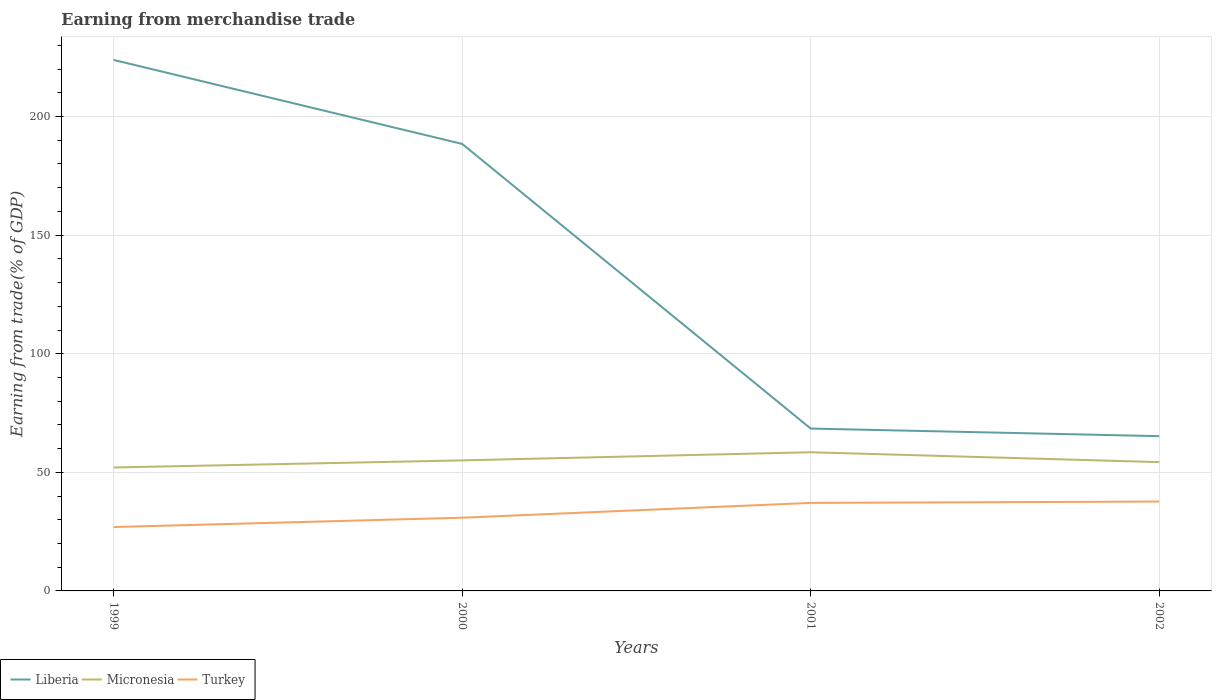Does the line corresponding to Micronesia intersect with the line corresponding to Turkey?
Make the answer very short. No. Is the number of lines equal to the number of legend labels?
Ensure brevity in your answer.  Yes. Across all years, what is the maximum earnings from trade in Liberia?
Give a very brief answer. 65.25. In which year was the earnings from trade in Liberia maximum?
Make the answer very short. 2002. What is the total earnings from trade in Micronesia in the graph?
Make the answer very short. -6.42. What is the difference between the highest and the second highest earnings from trade in Turkey?
Offer a very short reply. 10.75. What is the difference between the highest and the lowest earnings from trade in Micronesia?
Ensure brevity in your answer.  2. How many years are there in the graph?
Provide a short and direct response. 4. Does the graph contain grids?
Offer a very short reply. Yes. How are the legend labels stacked?
Offer a terse response. Horizontal. What is the title of the graph?
Your answer should be compact. Earning from merchandise trade. Does "Madagascar" appear as one of the legend labels in the graph?
Ensure brevity in your answer.  No. What is the label or title of the Y-axis?
Your response must be concise. Earning from trade(% of GDP). What is the Earning from trade(% of GDP) of Liberia in 1999?
Offer a very short reply. 223.86. What is the Earning from trade(% of GDP) of Micronesia in 1999?
Make the answer very short. 52.04. What is the Earning from trade(% of GDP) of Turkey in 1999?
Keep it short and to the point. 26.93. What is the Earning from trade(% of GDP) of Liberia in 2000?
Provide a short and direct response. 188.45. What is the Earning from trade(% of GDP) of Micronesia in 2000?
Your answer should be very brief. 55.04. What is the Earning from trade(% of GDP) in Turkey in 2000?
Offer a terse response. 30.87. What is the Earning from trade(% of GDP) of Liberia in 2001?
Keep it short and to the point. 68.45. What is the Earning from trade(% of GDP) of Micronesia in 2001?
Ensure brevity in your answer.  58.46. What is the Earning from trade(% of GDP) of Turkey in 2001?
Provide a short and direct response. 37.11. What is the Earning from trade(% of GDP) in Liberia in 2002?
Ensure brevity in your answer.  65.25. What is the Earning from trade(% of GDP) of Micronesia in 2002?
Your answer should be compact. 54.3. What is the Earning from trade(% of GDP) in Turkey in 2002?
Give a very brief answer. 37.68. Across all years, what is the maximum Earning from trade(% of GDP) of Liberia?
Your answer should be compact. 223.86. Across all years, what is the maximum Earning from trade(% of GDP) in Micronesia?
Make the answer very short. 58.46. Across all years, what is the maximum Earning from trade(% of GDP) of Turkey?
Your response must be concise. 37.68. Across all years, what is the minimum Earning from trade(% of GDP) of Liberia?
Your answer should be compact. 65.25. Across all years, what is the minimum Earning from trade(% of GDP) of Micronesia?
Your answer should be very brief. 52.04. Across all years, what is the minimum Earning from trade(% of GDP) of Turkey?
Give a very brief answer. 26.93. What is the total Earning from trade(% of GDP) of Liberia in the graph?
Offer a terse response. 546. What is the total Earning from trade(% of GDP) in Micronesia in the graph?
Provide a succinct answer. 219.84. What is the total Earning from trade(% of GDP) in Turkey in the graph?
Give a very brief answer. 132.58. What is the difference between the Earning from trade(% of GDP) in Liberia in 1999 and that in 2000?
Offer a very short reply. 35.41. What is the difference between the Earning from trade(% of GDP) in Micronesia in 1999 and that in 2000?
Provide a short and direct response. -3. What is the difference between the Earning from trade(% of GDP) in Turkey in 1999 and that in 2000?
Make the answer very short. -3.94. What is the difference between the Earning from trade(% of GDP) in Liberia in 1999 and that in 2001?
Provide a short and direct response. 155.41. What is the difference between the Earning from trade(% of GDP) in Micronesia in 1999 and that in 2001?
Keep it short and to the point. -6.42. What is the difference between the Earning from trade(% of GDP) of Turkey in 1999 and that in 2001?
Keep it short and to the point. -10.18. What is the difference between the Earning from trade(% of GDP) in Liberia in 1999 and that in 2002?
Ensure brevity in your answer.  158.61. What is the difference between the Earning from trade(% of GDP) of Micronesia in 1999 and that in 2002?
Give a very brief answer. -2.26. What is the difference between the Earning from trade(% of GDP) in Turkey in 1999 and that in 2002?
Your answer should be very brief. -10.75. What is the difference between the Earning from trade(% of GDP) of Liberia in 2000 and that in 2001?
Your response must be concise. 120. What is the difference between the Earning from trade(% of GDP) of Micronesia in 2000 and that in 2001?
Give a very brief answer. -3.42. What is the difference between the Earning from trade(% of GDP) in Turkey in 2000 and that in 2001?
Offer a terse response. -6.24. What is the difference between the Earning from trade(% of GDP) of Liberia in 2000 and that in 2002?
Give a very brief answer. 123.2. What is the difference between the Earning from trade(% of GDP) in Micronesia in 2000 and that in 2002?
Ensure brevity in your answer.  0.74. What is the difference between the Earning from trade(% of GDP) of Turkey in 2000 and that in 2002?
Provide a succinct answer. -6.81. What is the difference between the Earning from trade(% of GDP) in Liberia in 2001 and that in 2002?
Provide a short and direct response. 3.2. What is the difference between the Earning from trade(% of GDP) of Micronesia in 2001 and that in 2002?
Provide a succinct answer. 4.16. What is the difference between the Earning from trade(% of GDP) in Turkey in 2001 and that in 2002?
Your answer should be very brief. -0.57. What is the difference between the Earning from trade(% of GDP) in Liberia in 1999 and the Earning from trade(% of GDP) in Micronesia in 2000?
Keep it short and to the point. 168.82. What is the difference between the Earning from trade(% of GDP) in Liberia in 1999 and the Earning from trade(% of GDP) in Turkey in 2000?
Offer a terse response. 192.99. What is the difference between the Earning from trade(% of GDP) of Micronesia in 1999 and the Earning from trade(% of GDP) of Turkey in 2000?
Ensure brevity in your answer.  21.17. What is the difference between the Earning from trade(% of GDP) in Liberia in 1999 and the Earning from trade(% of GDP) in Micronesia in 2001?
Your response must be concise. 165.4. What is the difference between the Earning from trade(% of GDP) in Liberia in 1999 and the Earning from trade(% of GDP) in Turkey in 2001?
Ensure brevity in your answer.  186.75. What is the difference between the Earning from trade(% of GDP) in Micronesia in 1999 and the Earning from trade(% of GDP) in Turkey in 2001?
Offer a very short reply. 14.93. What is the difference between the Earning from trade(% of GDP) of Liberia in 1999 and the Earning from trade(% of GDP) of Micronesia in 2002?
Your answer should be very brief. 169.56. What is the difference between the Earning from trade(% of GDP) in Liberia in 1999 and the Earning from trade(% of GDP) in Turkey in 2002?
Your answer should be very brief. 186.18. What is the difference between the Earning from trade(% of GDP) of Micronesia in 1999 and the Earning from trade(% of GDP) of Turkey in 2002?
Offer a terse response. 14.36. What is the difference between the Earning from trade(% of GDP) in Liberia in 2000 and the Earning from trade(% of GDP) in Micronesia in 2001?
Offer a very short reply. 129.99. What is the difference between the Earning from trade(% of GDP) of Liberia in 2000 and the Earning from trade(% of GDP) of Turkey in 2001?
Keep it short and to the point. 151.34. What is the difference between the Earning from trade(% of GDP) in Micronesia in 2000 and the Earning from trade(% of GDP) in Turkey in 2001?
Make the answer very short. 17.93. What is the difference between the Earning from trade(% of GDP) in Liberia in 2000 and the Earning from trade(% of GDP) in Micronesia in 2002?
Offer a very short reply. 134.15. What is the difference between the Earning from trade(% of GDP) of Liberia in 2000 and the Earning from trade(% of GDP) of Turkey in 2002?
Offer a terse response. 150.77. What is the difference between the Earning from trade(% of GDP) of Micronesia in 2000 and the Earning from trade(% of GDP) of Turkey in 2002?
Offer a very short reply. 17.36. What is the difference between the Earning from trade(% of GDP) in Liberia in 2001 and the Earning from trade(% of GDP) in Micronesia in 2002?
Provide a short and direct response. 14.15. What is the difference between the Earning from trade(% of GDP) in Liberia in 2001 and the Earning from trade(% of GDP) in Turkey in 2002?
Make the answer very short. 30.77. What is the difference between the Earning from trade(% of GDP) of Micronesia in 2001 and the Earning from trade(% of GDP) of Turkey in 2002?
Provide a succinct answer. 20.78. What is the average Earning from trade(% of GDP) in Liberia per year?
Give a very brief answer. 136.5. What is the average Earning from trade(% of GDP) in Micronesia per year?
Your response must be concise. 54.96. What is the average Earning from trade(% of GDP) in Turkey per year?
Ensure brevity in your answer.  33.15. In the year 1999, what is the difference between the Earning from trade(% of GDP) of Liberia and Earning from trade(% of GDP) of Micronesia?
Your answer should be very brief. 171.82. In the year 1999, what is the difference between the Earning from trade(% of GDP) of Liberia and Earning from trade(% of GDP) of Turkey?
Your answer should be compact. 196.93. In the year 1999, what is the difference between the Earning from trade(% of GDP) in Micronesia and Earning from trade(% of GDP) in Turkey?
Make the answer very short. 25.11. In the year 2000, what is the difference between the Earning from trade(% of GDP) of Liberia and Earning from trade(% of GDP) of Micronesia?
Provide a short and direct response. 133.41. In the year 2000, what is the difference between the Earning from trade(% of GDP) in Liberia and Earning from trade(% of GDP) in Turkey?
Offer a terse response. 157.58. In the year 2000, what is the difference between the Earning from trade(% of GDP) of Micronesia and Earning from trade(% of GDP) of Turkey?
Ensure brevity in your answer.  24.17. In the year 2001, what is the difference between the Earning from trade(% of GDP) in Liberia and Earning from trade(% of GDP) in Micronesia?
Give a very brief answer. 9.99. In the year 2001, what is the difference between the Earning from trade(% of GDP) of Liberia and Earning from trade(% of GDP) of Turkey?
Ensure brevity in your answer.  31.34. In the year 2001, what is the difference between the Earning from trade(% of GDP) of Micronesia and Earning from trade(% of GDP) of Turkey?
Make the answer very short. 21.35. In the year 2002, what is the difference between the Earning from trade(% of GDP) in Liberia and Earning from trade(% of GDP) in Micronesia?
Your answer should be very brief. 10.95. In the year 2002, what is the difference between the Earning from trade(% of GDP) of Liberia and Earning from trade(% of GDP) of Turkey?
Provide a succinct answer. 27.57. In the year 2002, what is the difference between the Earning from trade(% of GDP) in Micronesia and Earning from trade(% of GDP) in Turkey?
Your response must be concise. 16.62. What is the ratio of the Earning from trade(% of GDP) of Liberia in 1999 to that in 2000?
Your answer should be very brief. 1.19. What is the ratio of the Earning from trade(% of GDP) in Micronesia in 1999 to that in 2000?
Your answer should be very brief. 0.95. What is the ratio of the Earning from trade(% of GDP) of Turkey in 1999 to that in 2000?
Your answer should be very brief. 0.87. What is the ratio of the Earning from trade(% of GDP) of Liberia in 1999 to that in 2001?
Keep it short and to the point. 3.27. What is the ratio of the Earning from trade(% of GDP) in Micronesia in 1999 to that in 2001?
Give a very brief answer. 0.89. What is the ratio of the Earning from trade(% of GDP) in Turkey in 1999 to that in 2001?
Provide a short and direct response. 0.73. What is the ratio of the Earning from trade(% of GDP) of Liberia in 1999 to that in 2002?
Offer a very short reply. 3.43. What is the ratio of the Earning from trade(% of GDP) of Micronesia in 1999 to that in 2002?
Provide a short and direct response. 0.96. What is the ratio of the Earning from trade(% of GDP) of Turkey in 1999 to that in 2002?
Ensure brevity in your answer.  0.71. What is the ratio of the Earning from trade(% of GDP) of Liberia in 2000 to that in 2001?
Give a very brief answer. 2.75. What is the ratio of the Earning from trade(% of GDP) in Micronesia in 2000 to that in 2001?
Your response must be concise. 0.94. What is the ratio of the Earning from trade(% of GDP) in Turkey in 2000 to that in 2001?
Provide a short and direct response. 0.83. What is the ratio of the Earning from trade(% of GDP) in Liberia in 2000 to that in 2002?
Your answer should be compact. 2.89. What is the ratio of the Earning from trade(% of GDP) in Micronesia in 2000 to that in 2002?
Your response must be concise. 1.01. What is the ratio of the Earning from trade(% of GDP) in Turkey in 2000 to that in 2002?
Offer a very short reply. 0.82. What is the ratio of the Earning from trade(% of GDP) of Liberia in 2001 to that in 2002?
Offer a very short reply. 1.05. What is the ratio of the Earning from trade(% of GDP) of Micronesia in 2001 to that in 2002?
Offer a terse response. 1.08. What is the ratio of the Earning from trade(% of GDP) in Turkey in 2001 to that in 2002?
Offer a very short reply. 0.98. What is the difference between the highest and the second highest Earning from trade(% of GDP) of Liberia?
Ensure brevity in your answer.  35.41. What is the difference between the highest and the second highest Earning from trade(% of GDP) of Micronesia?
Your answer should be compact. 3.42. What is the difference between the highest and the second highest Earning from trade(% of GDP) in Turkey?
Give a very brief answer. 0.57. What is the difference between the highest and the lowest Earning from trade(% of GDP) in Liberia?
Offer a very short reply. 158.61. What is the difference between the highest and the lowest Earning from trade(% of GDP) in Micronesia?
Offer a terse response. 6.42. What is the difference between the highest and the lowest Earning from trade(% of GDP) of Turkey?
Ensure brevity in your answer.  10.75. 